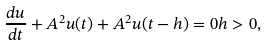Convert formula to latex. <formula><loc_0><loc_0><loc_500><loc_500>\frac { d u } { d t } + { A ^ { 2 } } u ( t ) + { A ^ { 2 } } u ( t - h ) = 0 h > 0 ,</formula> 